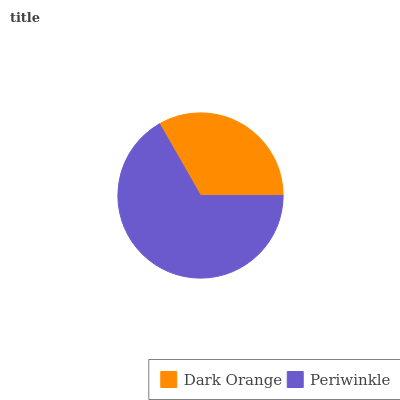Is Dark Orange the minimum?
Answer yes or no. Yes. Is Periwinkle the maximum?
Answer yes or no. Yes. Is Periwinkle the minimum?
Answer yes or no. No. Is Periwinkle greater than Dark Orange?
Answer yes or no. Yes. Is Dark Orange less than Periwinkle?
Answer yes or no. Yes. Is Dark Orange greater than Periwinkle?
Answer yes or no. No. Is Periwinkle less than Dark Orange?
Answer yes or no. No. Is Periwinkle the high median?
Answer yes or no. Yes. Is Dark Orange the low median?
Answer yes or no. Yes. Is Dark Orange the high median?
Answer yes or no. No. Is Periwinkle the low median?
Answer yes or no. No. 